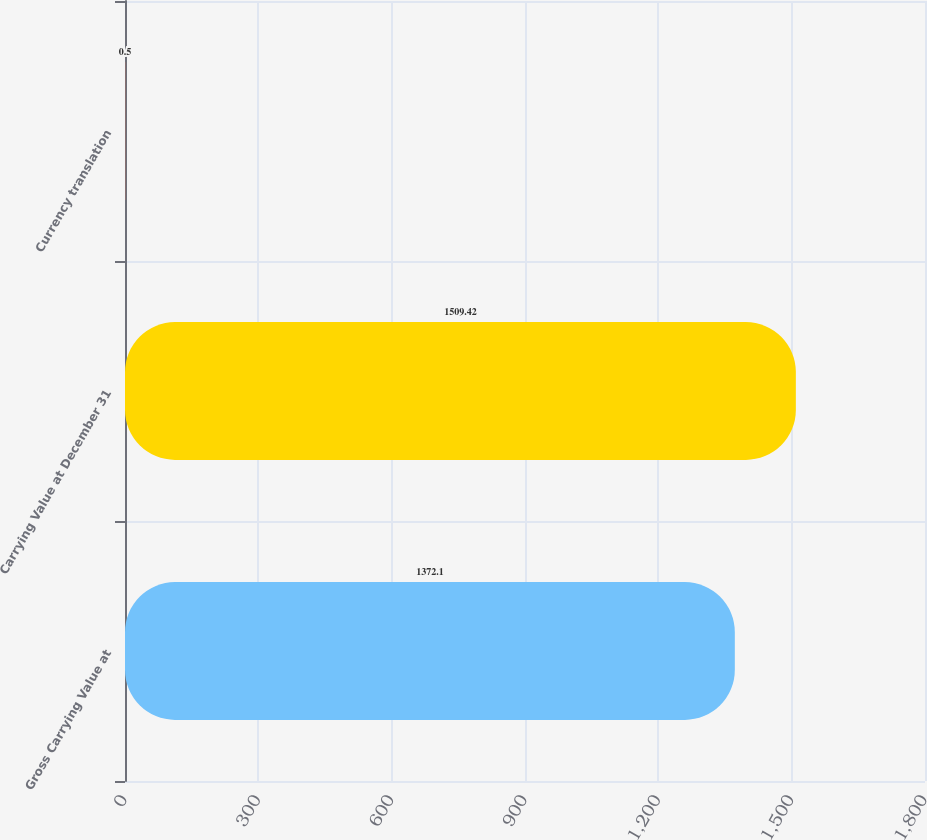Convert chart to OTSL. <chart><loc_0><loc_0><loc_500><loc_500><bar_chart><fcel>Gross Carrying Value at<fcel>Carrying Value at December 31<fcel>Currency translation<nl><fcel>1372.1<fcel>1509.42<fcel>0.5<nl></chart> 